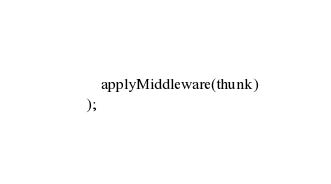Convert code to text. <code><loc_0><loc_0><loc_500><loc_500><_JavaScript_>    applyMiddleware(thunk)
);
</code> 